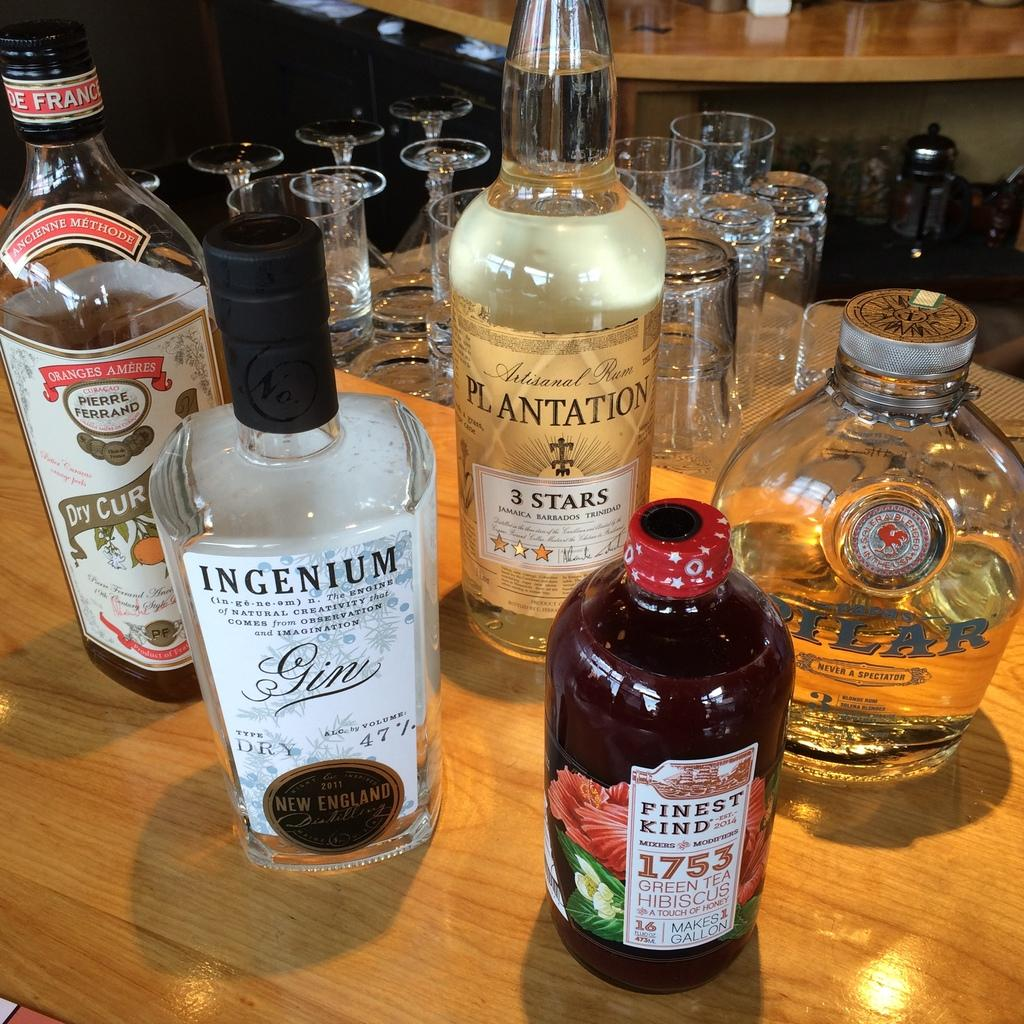Provide a one-sentence caption for the provided image. many alcohol bottles and one with France on it. 